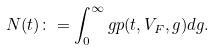<formula> <loc_0><loc_0><loc_500><loc_500>N ( t ) \colon = \int _ { 0 } ^ { \infty } g p ( t , V _ { F } , g ) d g .</formula> 